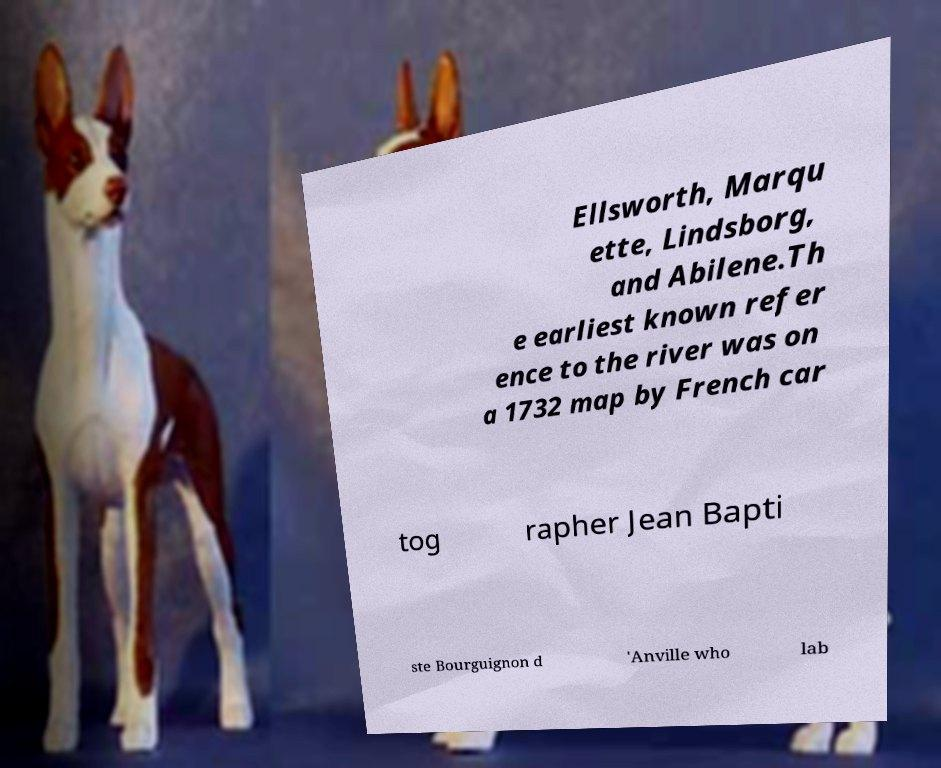Please read and relay the text visible in this image. What does it say? Ellsworth, Marqu ette, Lindsborg, and Abilene.Th e earliest known refer ence to the river was on a 1732 map by French car tog rapher Jean Bapti ste Bourguignon d 'Anville who lab 